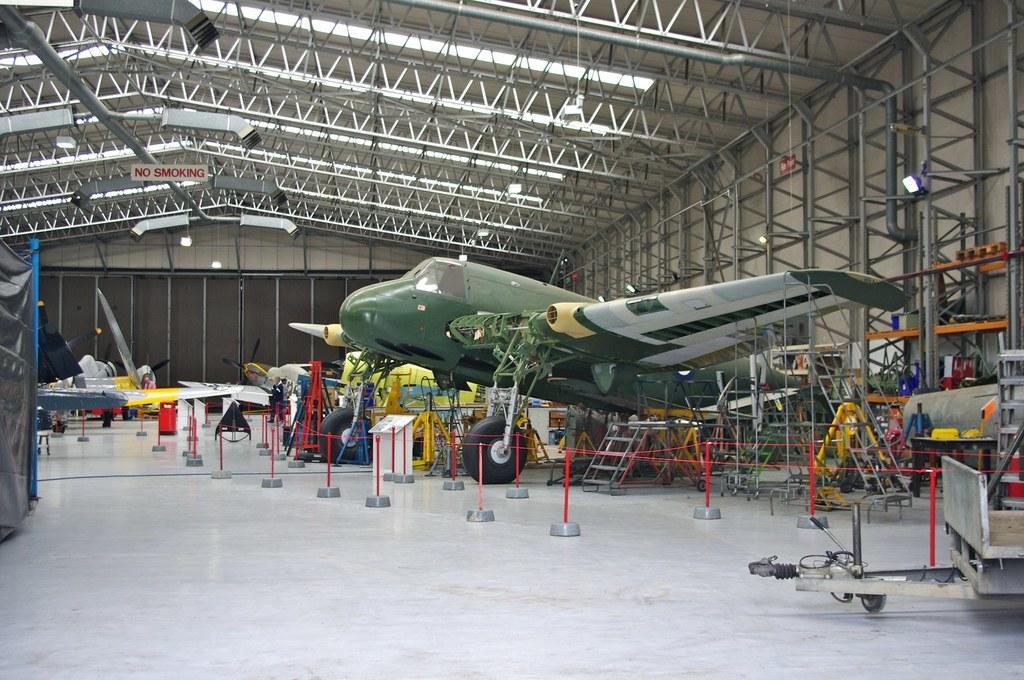<image>
Give a short and clear explanation of the subsequent image. Small aircraft hangar which does not allow smoking. 